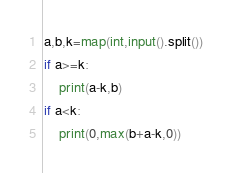Convert code to text. <code><loc_0><loc_0><loc_500><loc_500><_Python_>a,b,k=map(int,input().split())
if a>=k:
    print(a-k,b)
if a<k:
    print(0,max(b+a-k,0))</code> 